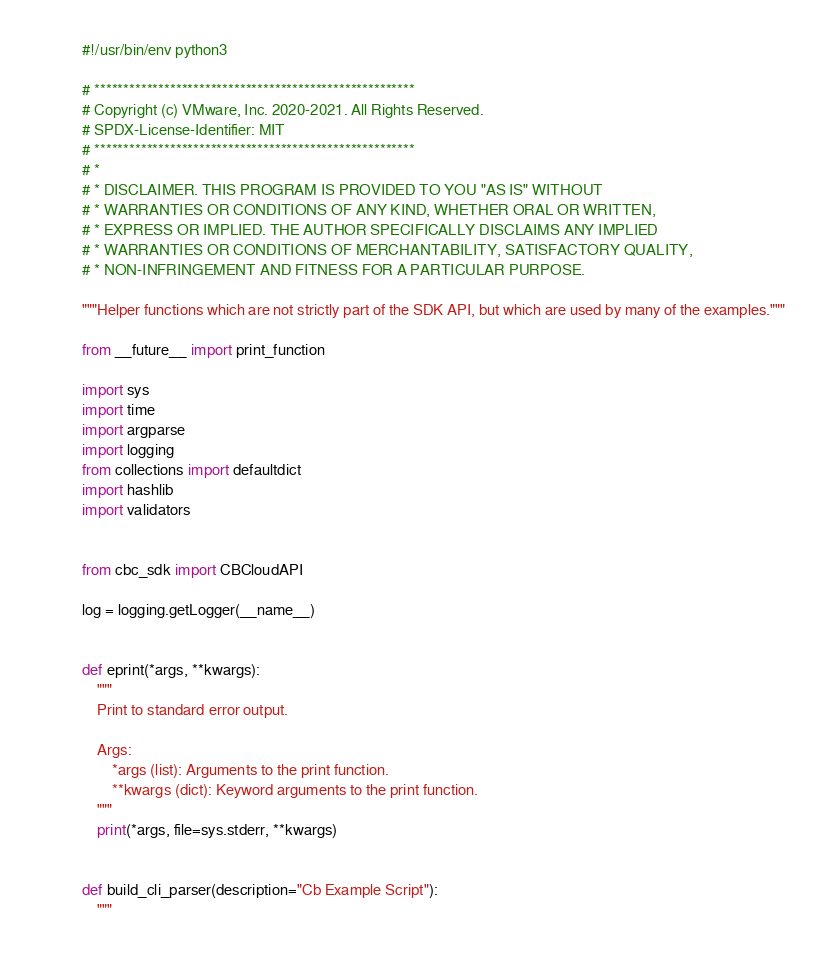<code> <loc_0><loc_0><loc_500><loc_500><_Python_>#!/usr/bin/env python3

# *******************************************************
# Copyright (c) VMware, Inc. 2020-2021. All Rights Reserved.
# SPDX-License-Identifier: MIT
# *******************************************************
# *
# * DISCLAIMER. THIS PROGRAM IS PROVIDED TO YOU "AS IS" WITHOUT
# * WARRANTIES OR CONDITIONS OF ANY KIND, WHETHER ORAL OR WRITTEN,
# * EXPRESS OR IMPLIED. THE AUTHOR SPECIFICALLY DISCLAIMS ANY IMPLIED
# * WARRANTIES OR CONDITIONS OF MERCHANTABILITY, SATISFACTORY QUALITY,
# * NON-INFRINGEMENT AND FITNESS FOR A PARTICULAR PURPOSE.

"""Helper functions which are not strictly part of the SDK API, but which are used by many of the examples."""

from __future__ import print_function

import sys
import time
import argparse
import logging
from collections import defaultdict
import hashlib
import validators


from cbc_sdk import CBCloudAPI

log = logging.getLogger(__name__)


def eprint(*args, **kwargs):
    """
    Print to standard error output.

    Args:
        *args (list): Arguments to the print function.
        **kwargs (dict): Keyword arguments to the print function.
    """
    print(*args, file=sys.stderr, **kwargs)


def build_cli_parser(description="Cb Example Script"):
    """</code> 